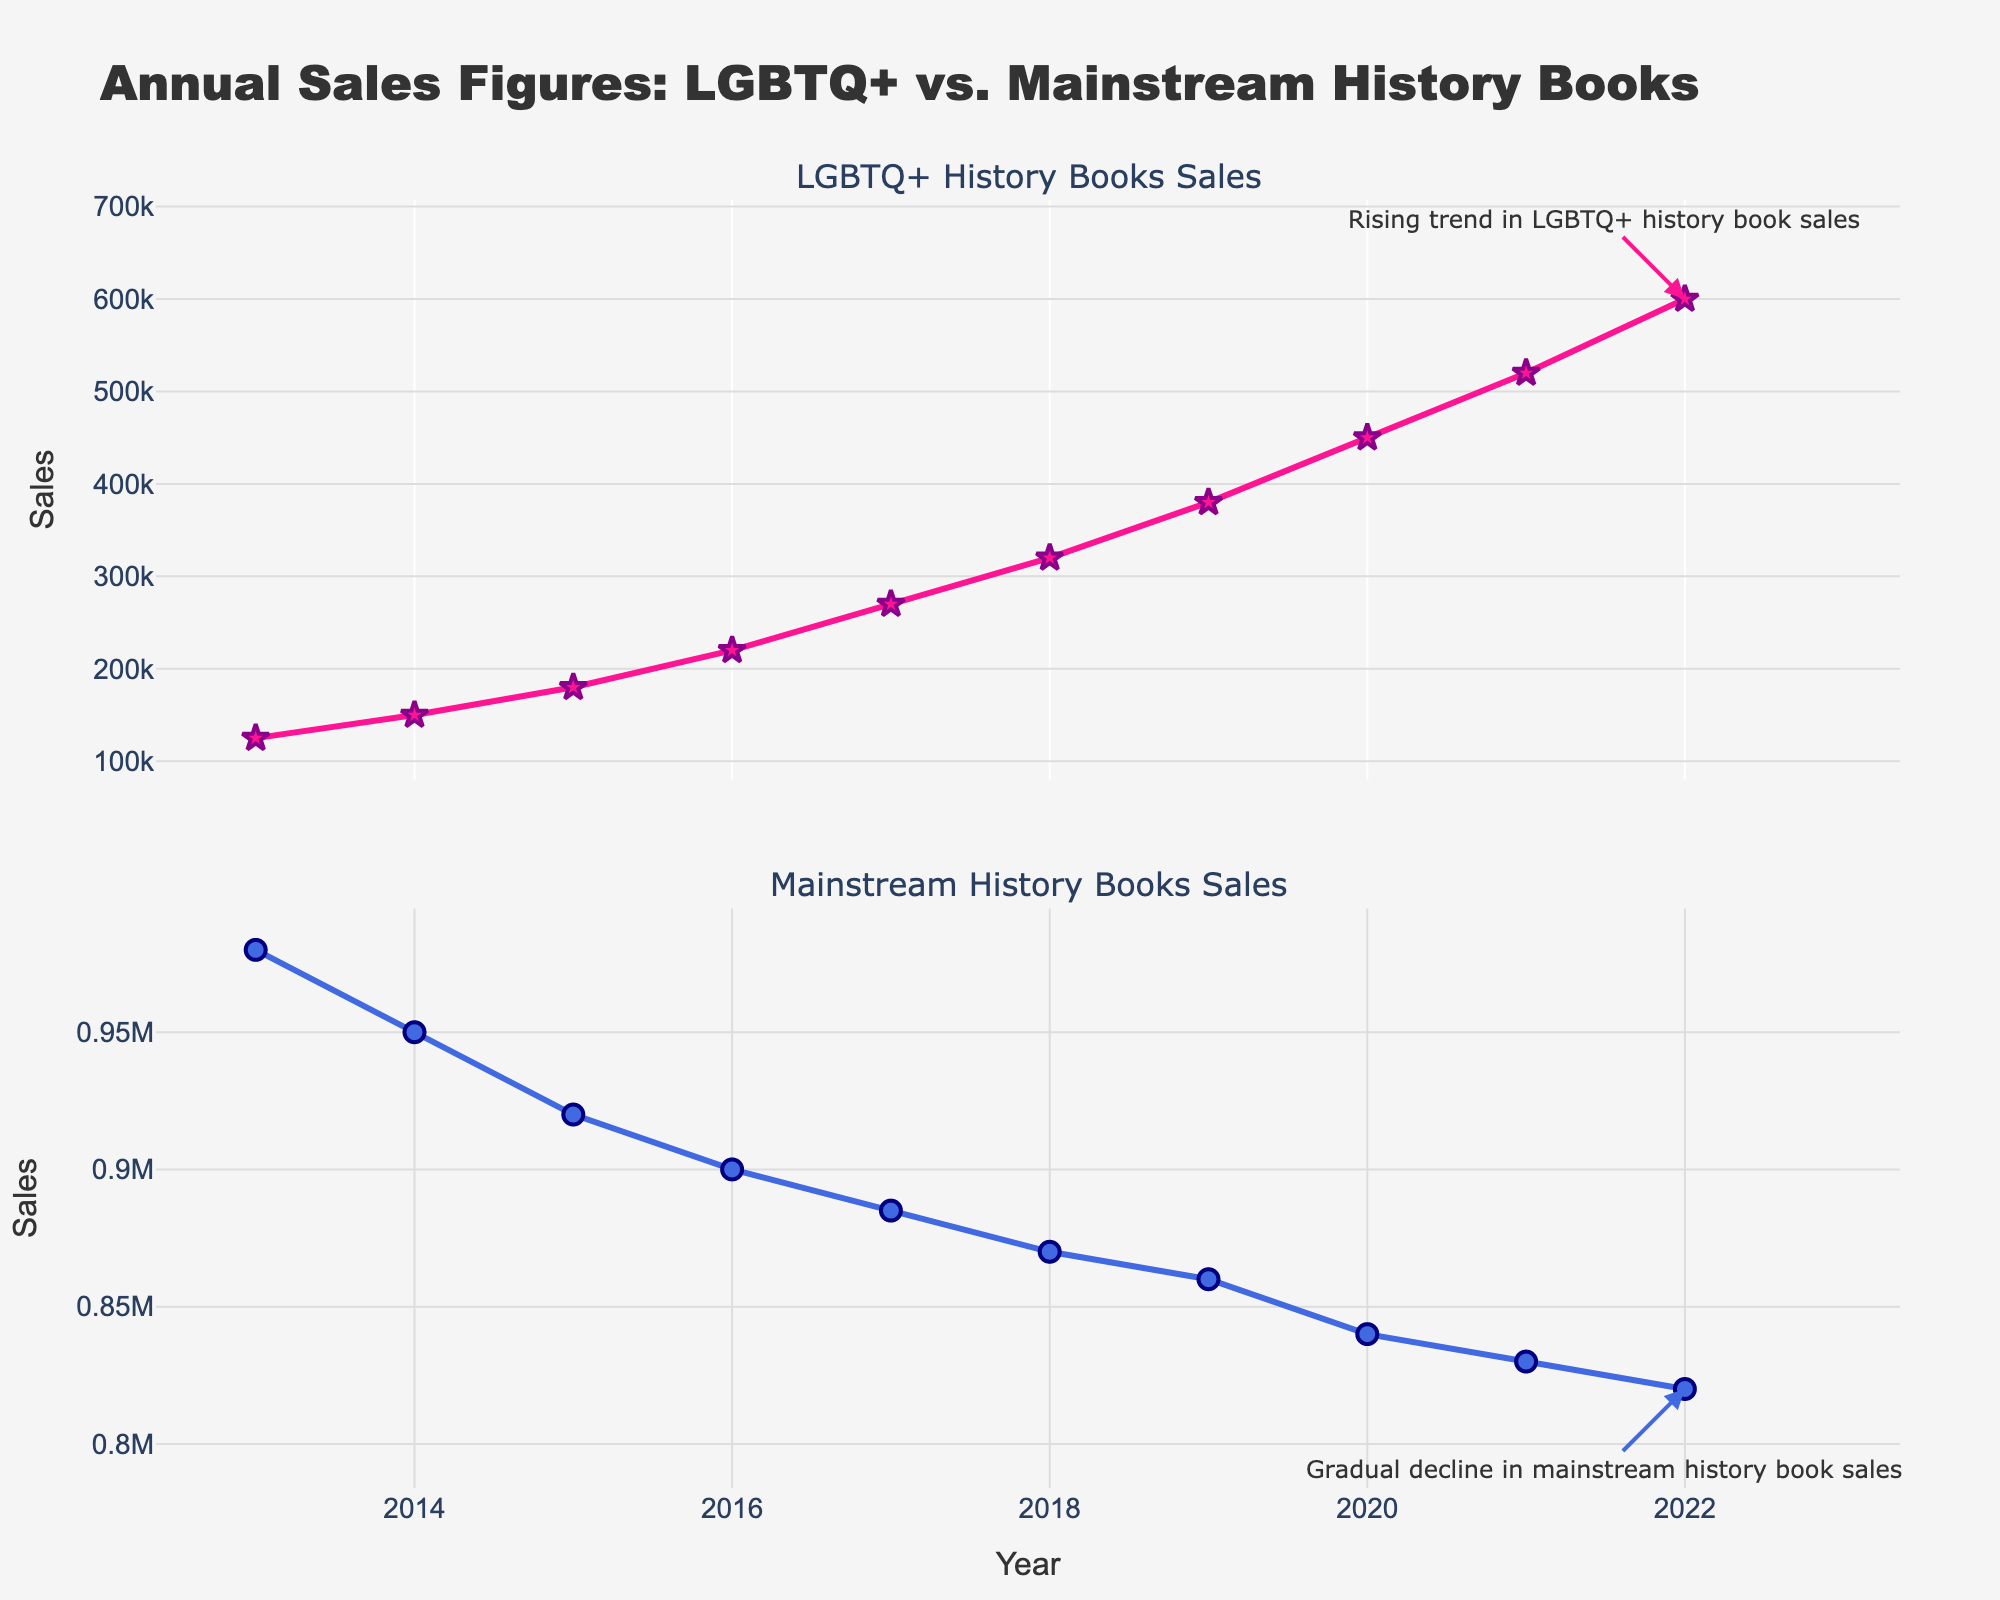What is the title of the figure? The title of the figure is located at the top of the plot. It helps to summarize the information presented.
Answer: Annual Sales Figures: LGBTQ+ vs. Mainstream History Books In which year did LGBTQ+ history books first surpass 200,000 in sales? Examine the trend line in the top subplot to see where the sales figure first crosses the 200,000 mark on the y-axis.
Answer: 2016 By how much did the sales of LGBTQ+ history books increase from 2013 to 2022? Subtract the sales figures of 2013 from 2022. The sales in 2013 were 125,000 and in 2022 were 600,000. So, 600,000 - 125,000 = 475,000.
Answer: 475,000 How do the trends in sales for LGBTQ+ history books compare to mainstream history books over the decade? Observe the overall direction of both trend lines. LGBTQ+ history books show a steadily increasing trend, while mainstream history books show a slight decline.
Answer: LGBTQ+ history books increased; mainstream history books slightly decreased Which category had higher sales in 2017, and by how much? Compare the sales figures of both categories for the year 2017. The sales for LGBTQ+ history books were 270,000 and for mainstream history books were 885,000. The difference is 885,000 - 270,000 = 615,000.
Answer: Mainstream history books by 615,000 What is the annotation text for the trend in sales of LGBTQ+ history books in 2022? Look at the annotation near the data point for 2022 in the top subplot. It highlights the trend in a specific trend color.
Answer: Rising trend in LGBTQ+ history book sales What was the approximate rate of sales increase per year for LGBTQ+ history books between 2013 and 2022? Calculate the average annual increase by dividing the total increase over the number of years (600,000 - 125,000) / (2022 - 2013). That is, 475,000 / 9 ≈ 52,778.
Answer: Approximately 52,778 per year Which year saw the lowest sales for mainstream history books, and what was the sales figure? Identify the data point with the lowest y-value in the bottom subplot. The sales figure for that year was 820,000 in 2022.
Answer: 2022 with 820,000 sales What specific pattern or trend is mentioned in the annotation for mainstream history books sales in 2022? Read the text of the annotation pointing to the 2022 data point in the bottom subplot. It mentions a specific trend in blue color.
Answer: Gradual decline in mainstream history book sales Based on the range and overall trend, which category shows more growth potential for future years? Examine the trend lines over the decade. LGBTQ+ history books show a strong upward trend, while mainstream history books have a downward trend.
Answer: LGBTQ+ history books 